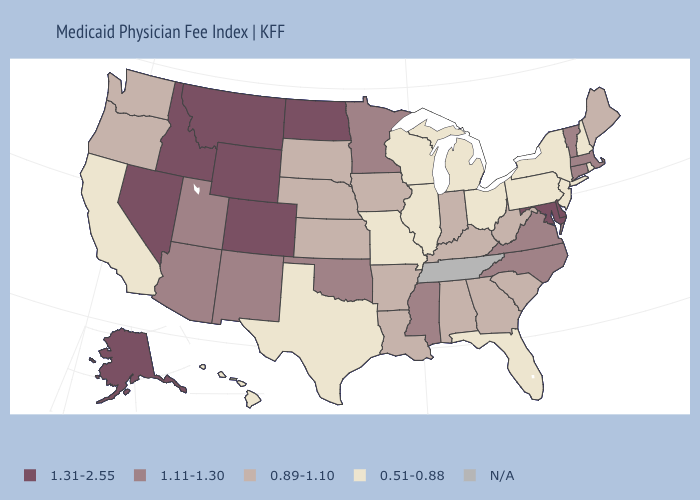What is the value of South Carolina?
Answer briefly. 0.89-1.10. Which states have the lowest value in the West?
Answer briefly. California, Hawaii. Among the states that border Pennsylvania , which have the lowest value?
Concise answer only. New Jersey, New York, Ohio. Which states have the highest value in the USA?
Short answer required. Alaska, Colorado, Delaware, Idaho, Maryland, Montana, Nevada, North Dakota, Wyoming. What is the value of Maine?
Be succinct. 0.89-1.10. Which states hav the highest value in the South?
Short answer required. Delaware, Maryland. What is the value of Missouri?
Short answer required. 0.51-0.88. What is the lowest value in the USA?
Write a very short answer. 0.51-0.88. What is the lowest value in the USA?
Quick response, please. 0.51-0.88. What is the lowest value in states that border Georgia?
Short answer required. 0.51-0.88. Name the states that have a value in the range 1.31-2.55?
Answer briefly. Alaska, Colorado, Delaware, Idaho, Maryland, Montana, Nevada, North Dakota, Wyoming. Does Kentucky have the lowest value in the USA?
Short answer required. No. 